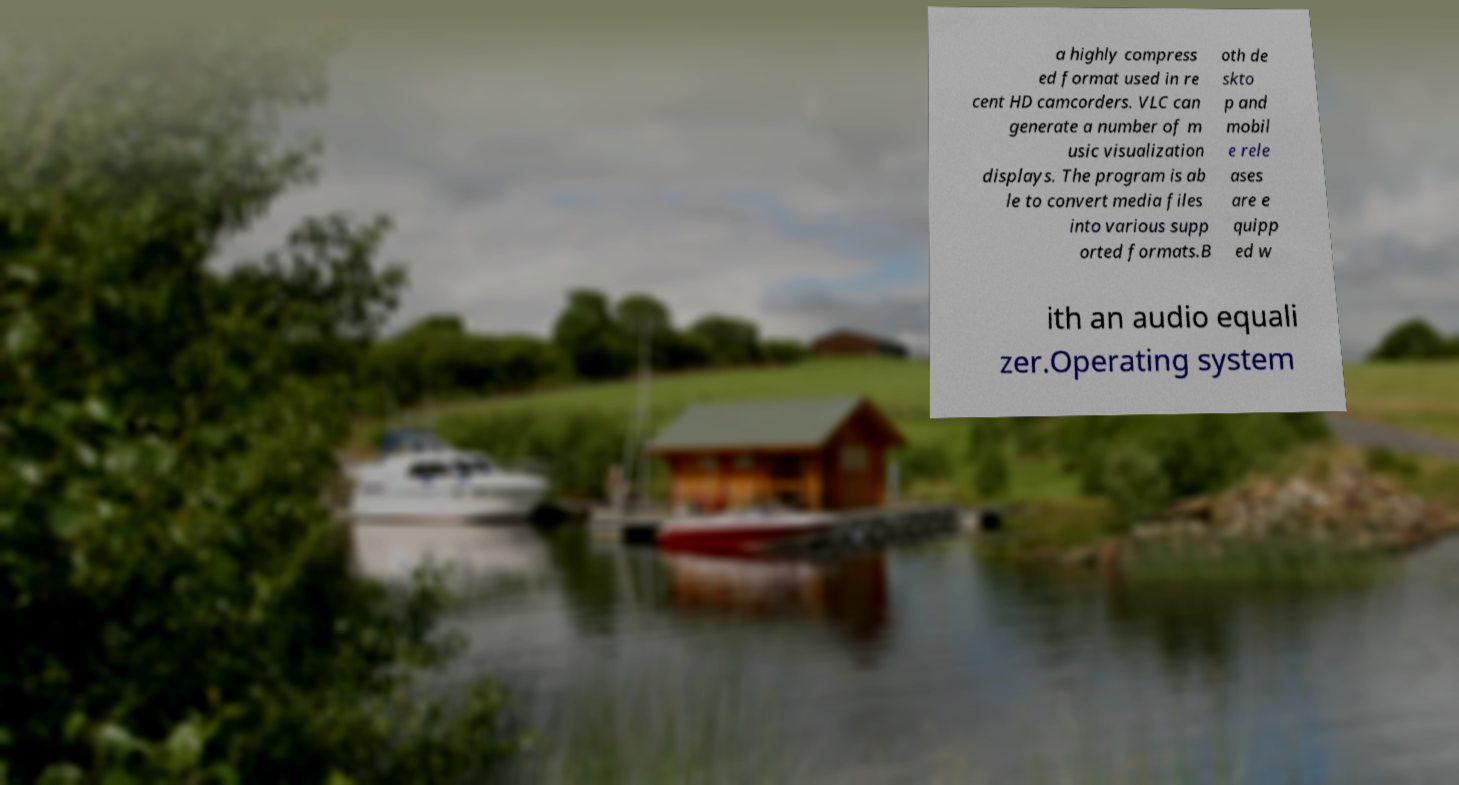There's text embedded in this image that I need extracted. Can you transcribe it verbatim? a highly compress ed format used in re cent HD camcorders. VLC can generate a number of m usic visualization displays. The program is ab le to convert media files into various supp orted formats.B oth de skto p and mobil e rele ases are e quipp ed w ith an audio equali zer.Operating system 